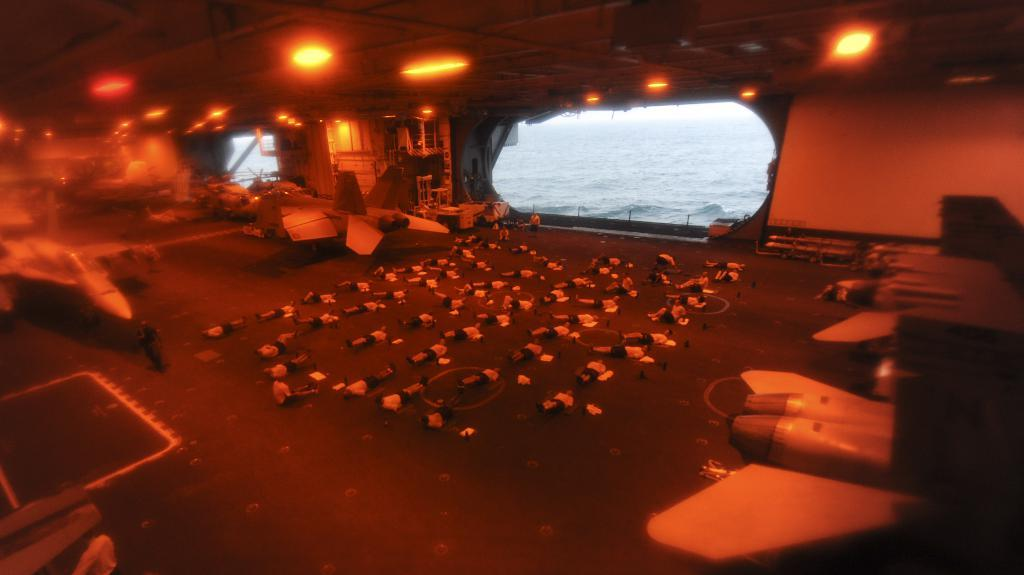What type of location is depicted in the image? The image is an inside view of a ship. What can be seen inside the ship? There are aircrafts, other objects, and lights visible inside the ship. How many glass windows are present in the ship? There are visible in the image? What can be seen through the windows? Water is visible through the windows. Reasoning: Let's think step by step by step in order to produce the conversation. We start by identifying the main location depicted in the image, which is the inside of a ship. Then, we describe the various objects and features that can be seen inside the ship, such as aircrafts, other objects, and lights. We also mention the presence of glass windows and what can be seen through them, which is water. Each question is designed to elicit a specific detail about the image that is known from the provided facts. Absurd Question/Answer: Where is the mine located in the image? There is no mine present in the image; it depicts an inside view of a ship with aircrafts, objects, lights, and windows. What type of fight is taking place in the image? There is no fight present in the image; it depicts an inside view of a ship with aircrafts, objects, lights, and windows. 